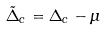<formula> <loc_0><loc_0><loc_500><loc_500>\tilde { \Delta } _ { c } = \Delta _ { c } - \mu</formula> 